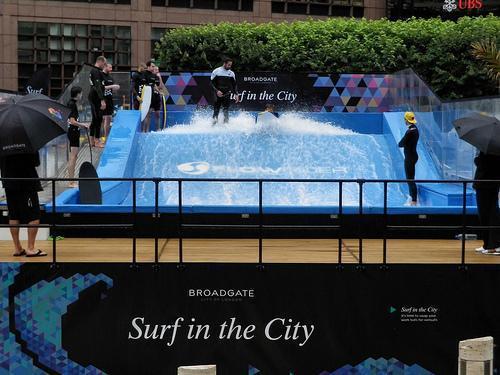How many people are holding umbrellas?
Give a very brief answer. 2. 